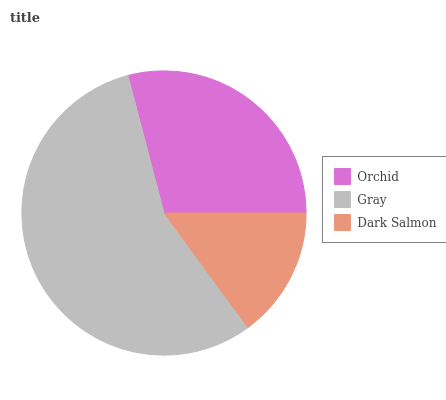Is Dark Salmon the minimum?
Answer yes or no. Yes. Is Gray the maximum?
Answer yes or no. Yes. Is Gray the minimum?
Answer yes or no. No. Is Dark Salmon the maximum?
Answer yes or no. No. Is Gray greater than Dark Salmon?
Answer yes or no. Yes. Is Dark Salmon less than Gray?
Answer yes or no. Yes. Is Dark Salmon greater than Gray?
Answer yes or no. No. Is Gray less than Dark Salmon?
Answer yes or no. No. Is Orchid the high median?
Answer yes or no. Yes. Is Orchid the low median?
Answer yes or no. Yes. Is Dark Salmon the high median?
Answer yes or no. No. Is Dark Salmon the low median?
Answer yes or no. No. 